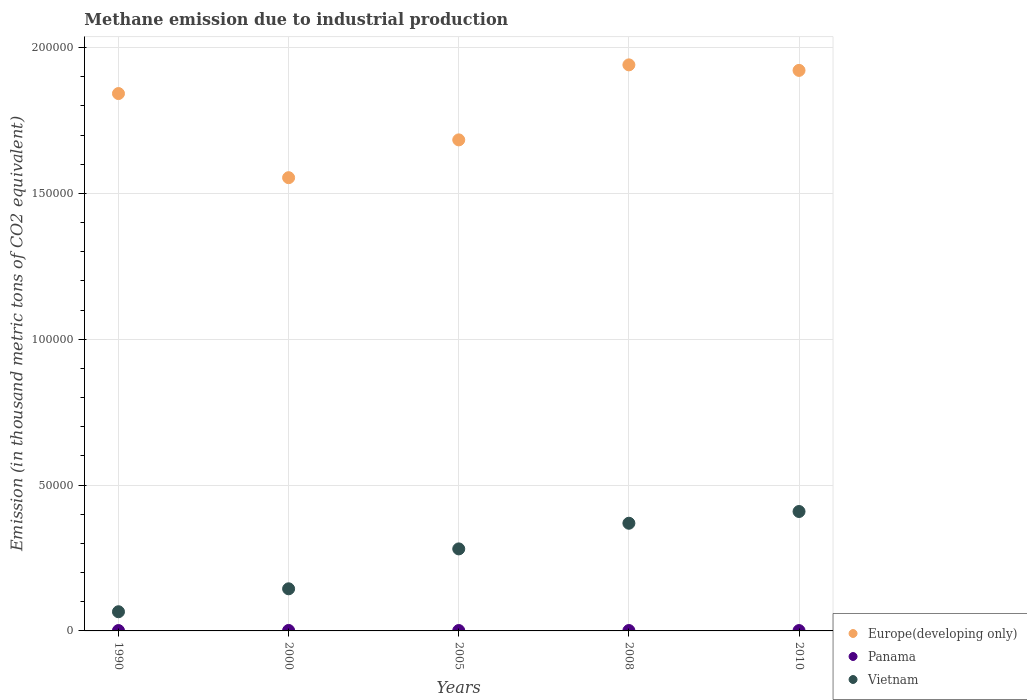How many different coloured dotlines are there?
Your answer should be compact. 3. Is the number of dotlines equal to the number of legend labels?
Offer a terse response. Yes. What is the amount of methane emitted in Vietnam in 1990?
Provide a succinct answer. 6574.5. Across all years, what is the maximum amount of methane emitted in Panama?
Your answer should be very brief. 161.8. Across all years, what is the minimum amount of methane emitted in Europe(developing only)?
Your response must be concise. 1.55e+05. In which year was the amount of methane emitted in Panama maximum?
Offer a very short reply. 2000. In which year was the amount of methane emitted in Vietnam minimum?
Keep it short and to the point. 1990. What is the total amount of methane emitted in Europe(developing only) in the graph?
Ensure brevity in your answer.  8.94e+05. What is the difference between the amount of methane emitted in Vietnam in 2005 and that in 2010?
Ensure brevity in your answer.  -1.28e+04. What is the difference between the amount of methane emitted in Panama in 2005 and the amount of methane emitted in Vietnam in 2008?
Give a very brief answer. -3.68e+04. What is the average amount of methane emitted in Europe(developing only) per year?
Give a very brief answer. 1.79e+05. In the year 1990, what is the difference between the amount of methane emitted in Panama and amount of methane emitted in Europe(developing only)?
Make the answer very short. -1.84e+05. In how many years, is the amount of methane emitted in Vietnam greater than 80000 thousand metric tons?
Your response must be concise. 0. What is the ratio of the amount of methane emitted in Panama in 1990 to that in 2010?
Your answer should be very brief. 1.04. Is the amount of methane emitted in Europe(developing only) in 2000 less than that in 2008?
Your answer should be very brief. Yes. What is the difference between the highest and the lowest amount of methane emitted in Panama?
Make the answer very short. 37.9. In how many years, is the amount of methane emitted in Europe(developing only) greater than the average amount of methane emitted in Europe(developing only) taken over all years?
Ensure brevity in your answer.  3. Is it the case that in every year, the sum of the amount of methane emitted in Vietnam and amount of methane emitted in Panama  is greater than the amount of methane emitted in Europe(developing only)?
Offer a terse response. No. How many dotlines are there?
Ensure brevity in your answer.  3. How many years are there in the graph?
Your response must be concise. 5. Does the graph contain any zero values?
Provide a succinct answer. No. How are the legend labels stacked?
Make the answer very short. Vertical. What is the title of the graph?
Ensure brevity in your answer.  Methane emission due to industrial production. Does "New Zealand" appear as one of the legend labels in the graph?
Offer a very short reply. No. What is the label or title of the X-axis?
Offer a terse response. Years. What is the label or title of the Y-axis?
Offer a terse response. Emission (in thousand metric tons of CO2 equivalent). What is the Emission (in thousand metric tons of CO2 equivalent) of Europe(developing only) in 1990?
Your answer should be very brief. 1.84e+05. What is the Emission (in thousand metric tons of CO2 equivalent) in Panama in 1990?
Keep it short and to the point. 128.9. What is the Emission (in thousand metric tons of CO2 equivalent) in Vietnam in 1990?
Offer a very short reply. 6574.5. What is the Emission (in thousand metric tons of CO2 equivalent) of Europe(developing only) in 2000?
Ensure brevity in your answer.  1.55e+05. What is the Emission (in thousand metric tons of CO2 equivalent) in Panama in 2000?
Keep it short and to the point. 161.8. What is the Emission (in thousand metric tons of CO2 equivalent) in Vietnam in 2000?
Make the answer very short. 1.44e+04. What is the Emission (in thousand metric tons of CO2 equivalent) in Europe(developing only) in 2005?
Provide a succinct answer. 1.68e+05. What is the Emission (in thousand metric tons of CO2 equivalent) in Panama in 2005?
Provide a succinct answer. 135.8. What is the Emission (in thousand metric tons of CO2 equivalent) of Vietnam in 2005?
Provide a short and direct response. 2.81e+04. What is the Emission (in thousand metric tons of CO2 equivalent) of Europe(developing only) in 2008?
Keep it short and to the point. 1.94e+05. What is the Emission (in thousand metric tons of CO2 equivalent) of Panama in 2008?
Your answer should be compact. 135.3. What is the Emission (in thousand metric tons of CO2 equivalent) of Vietnam in 2008?
Ensure brevity in your answer.  3.69e+04. What is the Emission (in thousand metric tons of CO2 equivalent) in Europe(developing only) in 2010?
Provide a succinct answer. 1.92e+05. What is the Emission (in thousand metric tons of CO2 equivalent) of Panama in 2010?
Make the answer very short. 123.9. What is the Emission (in thousand metric tons of CO2 equivalent) of Vietnam in 2010?
Make the answer very short. 4.09e+04. Across all years, what is the maximum Emission (in thousand metric tons of CO2 equivalent) in Europe(developing only)?
Make the answer very short. 1.94e+05. Across all years, what is the maximum Emission (in thousand metric tons of CO2 equivalent) in Panama?
Keep it short and to the point. 161.8. Across all years, what is the maximum Emission (in thousand metric tons of CO2 equivalent) of Vietnam?
Ensure brevity in your answer.  4.09e+04. Across all years, what is the minimum Emission (in thousand metric tons of CO2 equivalent) in Europe(developing only)?
Give a very brief answer. 1.55e+05. Across all years, what is the minimum Emission (in thousand metric tons of CO2 equivalent) in Panama?
Your answer should be compact. 123.9. Across all years, what is the minimum Emission (in thousand metric tons of CO2 equivalent) in Vietnam?
Give a very brief answer. 6574.5. What is the total Emission (in thousand metric tons of CO2 equivalent) in Europe(developing only) in the graph?
Make the answer very short. 8.94e+05. What is the total Emission (in thousand metric tons of CO2 equivalent) of Panama in the graph?
Ensure brevity in your answer.  685.7. What is the total Emission (in thousand metric tons of CO2 equivalent) in Vietnam in the graph?
Provide a short and direct response. 1.27e+05. What is the difference between the Emission (in thousand metric tons of CO2 equivalent) in Europe(developing only) in 1990 and that in 2000?
Your answer should be very brief. 2.88e+04. What is the difference between the Emission (in thousand metric tons of CO2 equivalent) in Panama in 1990 and that in 2000?
Ensure brevity in your answer.  -32.9. What is the difference between the Emission (in thousand metric tons of CO2 equivalent) in Vietnam in 1990 and that in 2000?
Offer a very short reply. -7863.6. What is the difference between the Emission (in thousand metric tons of CO2 equivalent) in Europe(developing only) in 1990 and that in 2005?
Offer a terse response. 1.59e+04. What is the difference between the Emission (in thousand metric tons of CO2 equivalent) in Panama in 1990 and that in 2005?
Offer a very short reply. -6.9. What is the difference between the Emission (in thousand metric tons of CO2 equivalent) of Vietnam in 1990 and that in 2005?
Keep it short and to the point. -2.15e+04. What is the difference between the Emission (in thousand metric tons of CO2 equivalent) of Europe(developing only) in 1990 and that in 2008?
Your answer should be very brief. -9838.5. What is the difference between the Emission (in thousand metric tons of CO2 equivalent) in Vietnam in 1990 and that in 2008?
Your response must be concise. -3.03e+04. What is the difference between the Emission (in thousand metric tons of CO2 equivalent) of Europe(developing only) in 1990 and that in 2010?
Provide a short and direct response. -7940.9. What is the difference between the Emission (in thousand metric tons of CO2 equivalent) of Vietnam in 1990 and that in 2010?
Provide a succinct answer. -3.44e+04. What is the difference between the Emission (in thousand metric tons of CO2 equivalent) of Europe(developing only) in 2000 and that in 2005?
Your answer should be compact. -1.30e+04. What is the difference between the Emission (in thousand metric tons of CO2 equivalent) in Vietnam in 2000 and that in 2005?
Offer a terse response. -1.37e+04. What is the difference between the Emission (in thousand metric tons of CO2 equivalent) in Europe(developing only) in 2000 and that in 2008?
Your answer should be very brief. -3.87e+04. What is the difference between the Emission (in thousand metric tons of CO2 equivalent) of Panama in 2000 and that in 2008?
Give a very brief answer. 26.5. What is the difference between the Emission (in thousand metric tons of CO2 equivalent) of Vietnam in 2000 and that in 2008?
Keep it short and to the point. -2.25e+04. What is the difference between the Emission (in thousand metric tons of CO2 equivalent) of Europe(developing only) in 2000 and that in 2010?
Offer a terse response. -3.68e+04. What is the difference between the Emission (in thousand metric tons of CO2 equivalent) of Panama in 2000 and that in 2010?
Offer a very short reply. 37.9. What is the difference between the Emission (in thousand metric tons of CO2 equivalent) of Vietnam in 2000 and that in 2010?
Your response must be concise. -2.65e+04. What is the difference between the Emission (in thousand metric tons of CO2 equivalent) of Europe(developing only) in 2005 and that in 2008?
Give a very brief answer. -2.57e+04. What is the difference between the Emission (in thousand metric tons of CO2 equivalent) in Vietnam in 2005 and that in 2008?
Ensure brevity in your answer.  -8796. What is the difference between the Emission (in thousand metric tons of CO2 equivalent) of Europe(developing only) in 2005 and that in 2010?
Your response must be concise. -2.38e+04. What is the difference between the Emission (in thousand metric tons of CO2 equivalent) in Vietnam in 2005 and that in 2010?
Offer a very short reply. -1.28e+04. What is the difference between the Emission (in thousand metric tons of CO2 equivalent) of Europe(developing only) in 2008 and that in 2010?
Keep it short and to the point. 1897.6. What is the difference between the Emission (in thousand metric tons of CO2 equivalent) in Vietnam in 2008 and that in 2010?
Provide a short and direct response. -4024.6. What is the difference between the Emission (in thousand metric tons of CO2 equivalent) of Europe(developing only) in 1990 and the Emission (in thousand metric tons of CO2 equivalent) of Panama in 2000?
Your response must be concise. 1.84e+05. What is the difference between the Emission (in thousand metric tons of CO2 equivalent) in Europe(developing only) in 1990 and the Emission (in thousand metric tons of CO2 equivalent) in Vietnam in 2000?
Ensure brevity in your answer.  1.70e+05. What is the difference between the Emission (in thousand metric tons of CO2 equivalent) in Panama in 1990 and the Emission (in thousand metric tons of CO2 equivalent) in Vietnam in 2000?
Your answer should be very brief. -1.43e+04. What is the difference between the Emission (in thousand metric tons of CO2 equivalent) in Europe(developing only) in 1990 and the Emission (in thousand metric tons of CO2 equivalent) in Panama in 2005?
Keep it short and to the point. 1.84e+05. What is the difference between the Emission (in thousand metric tons of CO2 equivalent) in Europe(developing only) in 1990 and the Emission (in thousand metric tons of CO2 equivalent) in Vietnam in 2005?
Provide a succinct answer. 1.56e+05. What is the difference between the Emission (in thousand metric tons of CO2 equivalent) of Panama in 1990 and the Emission (in thousand metric tons of CO2 equivalent) of Vietnam in 2005?
Your response must be concise. -2.80e+04. What is the difference between the Emission (in thousand metric tons of CO2 equivalent) of Europe(developing only) in 1990 and the Emission (in thousand metric tons of CO2 equivalent) of Panama in 2008?
Make the answer very short. 1.84e+05. What is the difference between the Emission (in thousand metric tons of CO2 equivalent) of Europe(developing only) in 1990 and the Emission (in thousand metric tons of CO2 equivalent) of Vietnam in 2008?
Ensure brevity in your answer.  1.47e+05. What is the difference between the Emission (in thousand metric tons of CO2 equivalent) of Panama in 1990 and the Emission (in thousand metric tons of CO2 equivalent) of Vietnam in 2008?
Offer a very short reply. -3.68e+04. What is the difference between the Emission (in thousand metric tons of CO2 equivalent) in Europe(developing only) in 1990 and the Emission (in thousand metric tons of CO2 equivalent) in Panama in 2010?
Your answer should be compact. 1.84e+05. What is the difference between the Emission (in thousand metric tons of CO2 equivalent) in Europe(developing only) in 1990 and the Emission (in thousand metric tons of CO2 equivalent) in Vietnam in 2010?
Your answer should be very brief. 1.43e+05. What is the difference between the Emission (in thousand metric tons of CO2 equivalent) in Panama in 1990 and the Emission (in thousand metric tons of CO2 equivalent) in Vietnam in 2010?
Offer a very short reply. -4.08e+04. What is the difference between the Emission (in thousand metric tons of CO2 equivalent) of Europe(developing only) in 2000 and the Emission (in thousand metric tons of CO2 equivalent) of Panama in 2005?
Give a very brief answer. 1.55e+05. What is the difference between the Emission (in thousand metric tons of CO2 equivalent) in Europe(developing only) in 2000 and the Emission (in thousand metric tons of CO2 equivalent) in Vietnam in 2005?
Ensure brevity in your answer.  1.27e+05. What is the difference between the Emission (in thousand metric tons of CO2 equivalent) in Panama in 2000 and the Emission (in thousand metric tons of CO2 equivalent) in Vietnam in 2005?
Your response must be concise. -2.80e+04. What is the difference between the Emission (in thousand metric tons of CO2 equivalent) of Europe(developing only) in 2000 and the Emission (in thousand metric tons of CO2 equivalent) of Panama in 2008?
Offer a terse response. 1.55e+05. What is the difference between the Emission (in thousand metric tons of CO2 equivalent) in Europe(developing only) in 2000 and the Emission (in thousand metric tons of CO2 equivalent) in Vietnam in 2008?
Provide a short and direct response. 1.18e+05. What is the difference between the Emission (in thousand metric tons of CO2 equivalent) of Panama in 2000 and the Emission (in thousand metric tons of CO2 equivalent) of Vietnam in 2008?
Provide a succinct answer. -3.68e+04. What is the difference between the Emission (in thousand metric tons of CO2 equivalent) of Europe(developing only) in 2000 and the Emission (in thousand metric tons of CO2 equivalent) of Panama in 2010?
Your answer should be compact. 1.55e+05. What is the difference between the Emission (in thousand metric tons of CO2 equivalent) of Europe(developing only) in 2000 and the Emission (in thousand metric tons of CO2 equivalent) of Vietnam in 2010?
Make the answer very short. 1.14e+05. What is the difference between the Emission (in thousand metric tons of CO2 equivalent) in Panama in 2000 and the Emission (in thousand metric tons of CO2 equivalent) in Vietnam in 2010?
Keep it short and to the point. -4.08e+04. What is the difference between the Emission (in thousand metric tons of CO2 equivalent) in Europe(developing only) in 2005 and the Emission (in thousand metric tons of CO2 equivalent) in Panama in 2008?
Provide a short and direct response. 1.68e+05. What is the difference between the Emission (in thousand metric tons of CO2 equivalent) in Europe(developing only) in 2005 and the Emission (in thousand metric tons of CO2 equivalent) in Vietnam in 2008?
Give a very brief answer. 1.31e+05. What is the difference between the Emission (in thousand metric tons of CO2 equivalent) of Panama in 2005 and the Emission (in thousand metric tons of CO2 equivalent) of Vietnam in 2008?
Offer a very short reply. -3.68e+04. What is the difference between the Emission (in thousand metric tons of CO2 equivalent) of Europe(developing only) in 2005 and the Emission (in thousand metric tons of CO2 equivalent) of Panama in 2010?
Offer a terse response. 1.68e+05. What is the difference between the Emission (in thousand metric tons of CO2 equivalent) in Europe(developing only) in 2005 and the Emission (in thousand metric tons of CO2 equivalent) in Vietnam in 2010?
Your response must be concise. 1.27e+05. What is the difference between the Emission (in thousand metric tons of CO2 equivalent) in Panama in 2005 and the Emission (in thousand metric tons of CO2 equivalent) in Vietnam in 2010?
Offer a terse response. -4.08e+04. What is the difference between the Emission (in thousand metric tons of CO2 equivalent) in Europe(developing only) in 2008 and the Emission (in thousand metric tons of CO2 equivalent) in Panama in 2010?
Provide a succinct answer. 1.94e+05. What is the difference between the Emission (in thousand metric tons of CO2 equivalent) of Europe(developing only) in 2008 and the Emission (in thousand metric tons of CO2 equivalent) of Vietnam in 2010?
Ensure brevity in your answer.  1.53e+05. What is the difference between the Emission (in thousand metric tons of CO2 equivalent) in Panama in 2008 and the Emission (in thousand metric tons of CO2 equivalent) in Vietnam in 2010?
Your response must be concise. -4.08e+04. What is the average Emission (in thousand metric tons of CO2 equivalent) of Europe(developing only) per year?
Provide a short and direct response. 1.79e+05. What is the average Emission (in thousand metric tons of CO2 equivalent) in Panama per year?
Give a very brief answer. 137.14. What is the average Emission (in thousand metric tons of CO2 equivalent) of Vietnam per year?
Offer a very short reply. 2.54e+04. In the year 1990, what is the difference between the Emission (in thousand metric tons of CO2 equivalent) in Europe(developing only) and Emission (in thousand metric tons of CO2 equivalent) in Panama?
Your answer should be very brief. 1.84e+05. In the year 1990, what is the difference between the Emission (in thousand metric tons of CO2 equivalent) in Europe(developing only) and Emission (in thousand metric tons of CO2 equivalent) in Vietnam?
Offer a terse response. 1.78e+05. In the year 1990, what is the difference between the Emission (in thousand metric tons of CO2 equivalent) in Panama and Emission (in thousand metric tons of CO2 equivalent) in Vietnam?
Provide a succinct answer. -6445.6. In the year 2000, what is the difference between the Emission (in thousand metric tons of CO2 equivalent) in Europe(developing only) and Emission (in thousand metric tons of CO2 equivalent) in Panama?
Offer a terse response. 1.55e+05. In the year 2000, what is the difference between the Emission (in thousand metric tons of CO2 equivalent) in Europe(developing only) and Emission (in thousand metric tons of CO2 equivalent) in Vietnam?
Ensure brevity in your answer.  1.41e+05. In the year 2000, what is the difference between the Emission (in thousand metric tons of CO2 equivalent) in Panama and Emission (in thousand metric tons of CO2 equivalent) in Vietnam?
Offer a terse response. -1.43e+04. In the year 2005, what is the difference between the Emission (in thousand metric tons of CO2 equivalent) in Europe(developing only) and Emission (in thousand metric tons of CO2 equivalent) in Panama?
Your response must be concise. 1.68e+05. In the year 2005, what is the difference between the Emission (in thousand metric tons of CO2 equivalent) in Europe(developing only) and Emission (in thousand metric tons of CO2 equivalent) in Vietnam?
Make the answer very short. 1.40e+05. In the year 2005, what is the difference between the Emission (in thousand metric tons of CO2 equivalent) in Panama and Emission (in thousand metric tons of CO2 equivalent) in Vietnam?
Your response must be concise. -2.80e+04. In the year 2008, what is the difference between the Emission (in thousand metric tons of CO2 equivalent) in Europe(developing only) and Emission (in thousand metric tons of CO2 equivalent) in Panama?
Offer a very short reply. 1.94e+05. In the year 2008, what is the difference between the Emission (in thousand metric tons of CO2 equivalent) in Europe(developing only) and Emission (in thousand metric tons of CO2 equivalent) in Vietnam?
Make the answer very short. 1.57e+05. In the year 2008, what is the difference between the Emission (in thousand metric tons of CO2 equivalent) of Panama and Emission (in thousand metric tons of CO2 equivalent) of Vietnam?
Your answer should be very brief. -3.68e+04. In the year 2010, what is the difference between the Emission (in thousand metric tons of CO2 equivalent) of Europe(developing only) and Emission (in thousand metric tons of CO2 equivalent) of Panama?
Your answer should be compact. 1.92e+05. In the year 2010, what is the difference between the Emission (in thousand metric tons of CO2 equivalent) in Europe(developing only) and Emission (in thousand metric tons of CO2 equivalent) in Vietnam?
Give a very brief answer. 1.51e+05. In the year 2010, what is the difference between the Emission (in thousand metric tons of CO2 equivalent) in Panama and Emission (in thousand metric tons of CO2 equivalent) in Vietnam?
Provide a short and direct response. -4.08e+04. What is the ratio of the Emission (in thousand metric tons of CO2 equivalent) of Europe(developing only) in 1990 to that in 2000?
Keep it short and to the point. 1.19. What is the ratio of the Emission (in thousand metric tons of CO2 equivalent) in Panama in 1990 to that in 2000?
Your response must be concise. 0.8. What is the ratio of the Emission (in thousand metric tons of CO2 equivalent) of Vietnam in 1990 to that in 2000?
Provide a succinct answer. 0.46. What is the ratio of the Emission (in thousand metric tons of CO2 equivalent) of Europe(developing only) in 1990 to that in 2005?
Give a very brief answer. 1.09. What is the ratio of the Emission (in thousand metric tons of CO2 equivalent) of Panama in 1990 to that in 2005?
Give a very brief answer. 0.95. What is the ratio of the Emission (in thousand metric tons of CO2 equivalent) of Vietnam in 1990 to that in 2005?
Give a very brief answer. 0.23. What is the ratio of the Emission (in thousand metric tons of CO2 equivalent) of Europe(developing only) in 1990 to that in 2008?
Your answer should be compact. 0.95. What is the ratio of the Emission (in thousand metric tons of CO2 equivalent) of Panama in 1990 to that in 2008?
Make the answer very short. 0.95. What is the ratio of the Emission (in thousand metric tons of CO2 equivalent) in Vietnam in 1990 to that in 2008?
Provide a short and direct response. 0.18. What is the ratio of the Emission (in thousand metric tons of CO2 equivalent) of Europe(developing only) in 1990 to that in 2010?
Give a very brief answer. 0.96. What is the ratio of the Emission (in thousand metric tons of CO2 equivalent) of Panama in 1990 to that in 2010?
Make the answer very short. 1.04. What is the ratio of the Emission (in thousand metric tons of CO2 equivalent) in Vietnam in 1990 to that in 2010?
Keep it short and to the point. 0.16. What is the ratio of the Emission (in thousand metric tons of CO2 equivalent) of Europe(developing only) in 2000 to that in 2005?
Give a very brief answer. 0.92. What is the ratio of the Emission (in thousand metric tons of CO2 equivalent) of Panama in 2000 to that in 2005?
Your answer should be compact. 1.19. What is the ratio of the Emission (in thousand metric tons of CO2 equivalent) in Vietnam in 2000 to that in 2005?
Give a very brief answer. 0.51. What is the ratio of the Emission (in thousand metric tons of CO2 equivalent) in Europe(developing only) in 2000 to that in 2008?
Offer a terse response. 0.8. What is the ratio of the Emission (in thousand metric tons of CO2 equivalent) of Panama in 2000 to that in 2008?
Your response must be concise. 1.2. What is the ratio of the Emission (in thousand metric tons of CO2 equivalent) of Vietnam in 2000 to that in 2008?
Keep it short and to the point. 0.39. What is the ratio of the Emission (in thousand metric tons of CO2 equivalent) in Europe(developing only) in 2000 to that in 2010?
Offer a terse response. 0.81. What is the ratio of the Emission (in thousand metric tons of CO2 equivalent) in Panama in 2000 to that in 2010?
Give a very brief answer. 1.31. What is the ratio of the Emission (in thousand metric tons of CO2 equivalent) in Vietnam in 2000 to that in 2010?
Give a very brief answer. 0.35. What is the ratio of the Emission (in thousand metric tons of CO2 equivalent) in Europe(developing only) in 2005 to that in 2008?
Ensure brevity in your answer.  0.87. What is the ratio of the Emission (in thousand metric tons of CO2 equivalent) of Panama in 2005 to that in 2008?
Make the answer very short. 1. What is the ratio of the Emission (in thousand metric tons of CO2 equivalent) of Vietnam in 2005 to that in 2008?
Offer a very short reply. 0.76. What is the ratio of the Emission (in thousand metric tons of CO2 equivalent) of Europe(developing only) in 2005 to that in 2010?
Your answer should be very brief. 0.88. What is the ratio of the Emission (in thousand metric tons of CO2 equivalent) of Panama in 2005 to that in 2010?
Your answer should be compact. 1.1. What is the ratio of the Emission (in thousand metric tons of CO2 equivalent) of Vietnam in 2005 to that in 2010?
Your answer should be compact. 0.69. What is the ratio of the Emission (in thousand metric tons of CO2 equivalent) of Europe(developing only) in 2008 to that in 2010?
Give a very brief answer. 1.01. What is the ratio of the Emission (in thousand metric tons of CO2 equivalent) of Panama in 2008 to that in 2010?
Your answer should be very brief. 1.09. What is the ratio of the Emission (in thousand metric tons of CO2 equivalent) of Vietnam in 2008 to that in 2010?
Offer a very short reply. 0.9. What is the difference between the highest and the second highest Emission (in thousand metric tons of CO2 equivalent) in Europe(developing only)?
Keep it short and to the point. 1897.6. What is the difference between the highest and the second highest Emission (in thousand metric tons of CO2 equivalent) in Panama?
Your answer should be compact. 26. What is the difference between the highest and the second highest Emission (in thousand metric tons of CO2 equivalent) in Vietnam?
Provide a short and direct response. 4024.6. What is the difference between the highest and the lowest Emission (in thousand metric tons of CO2 equivalent) of Europe(developing only)?
Provide a short and direct response. 3.87e+04. What is the difference between the highest and the lowest Emission (in thousand metric tons of CO2 equivalent) of Panama?
Provide a short and direct response. 37.9. What is the difference between the highest and the lowest Emission (in thousand metric tons of CO2 equivalent) of Vietnam?
Offer a terse response. 3.44e+04. 